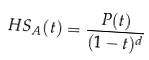<formula> <loc_0><loc_0><loc_500><loc_500>H S _ { A } ( t ) = \frac { P ( t ) } { ( 1 - t ) ^ { d } }</formula> 